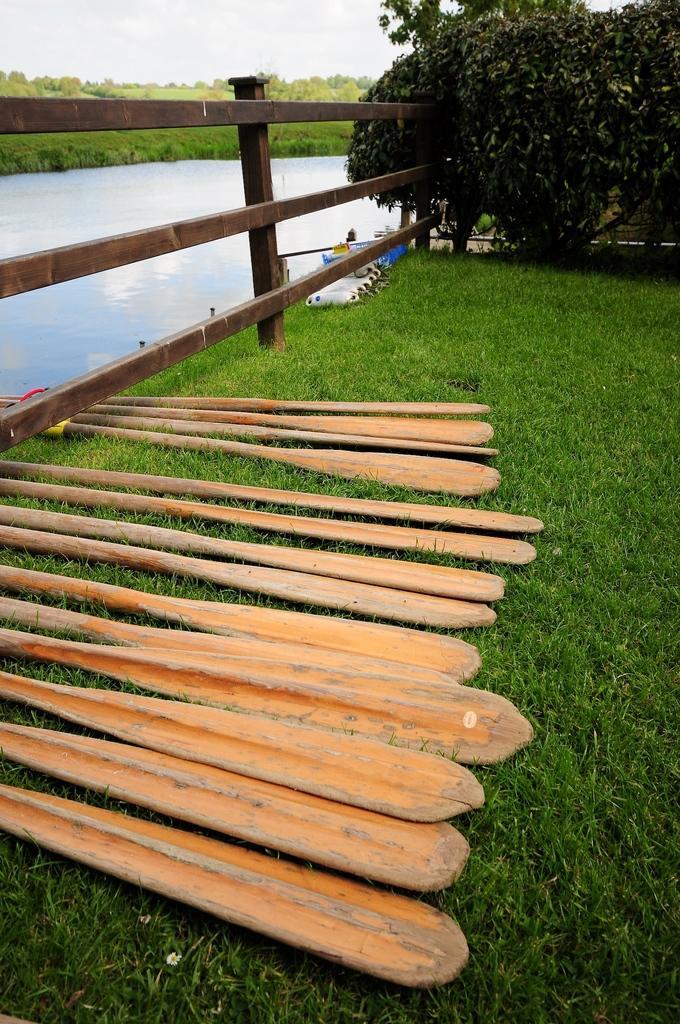Please provide a concise description of this image. At the bottom we can see paddles on the grass on the ground and we can see fence at the water. In the background there are trees and grass on the ground and we can see the sky. On the right side there is a plant and objects on the grass on the ground. 